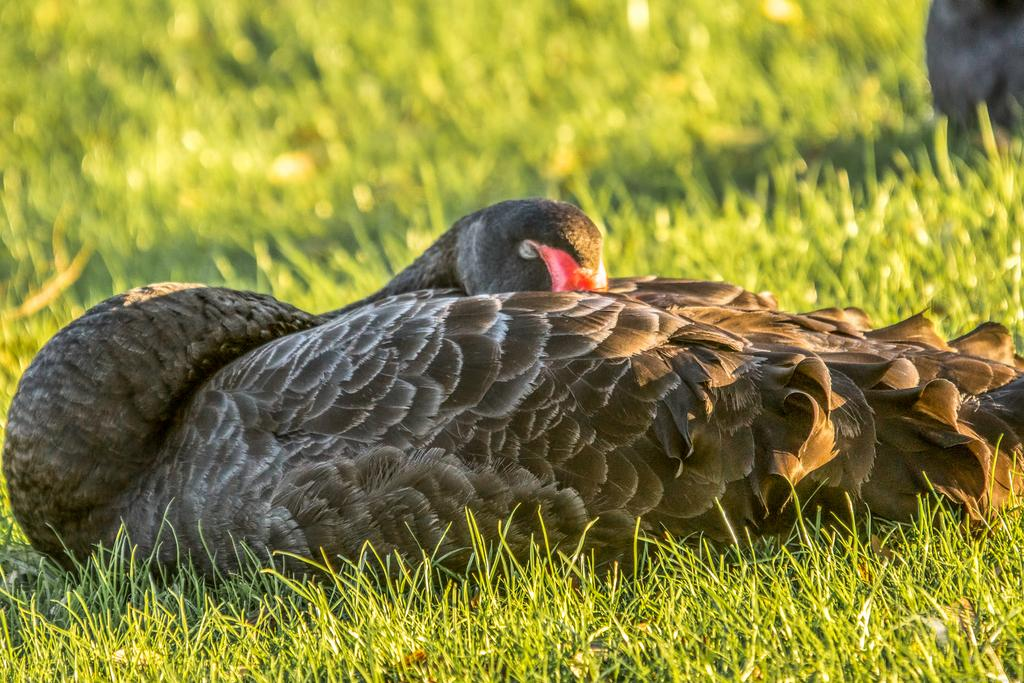What type of animal can be seen in the image? There is a bird in the image. Where is the bird located? The bird is sitting on the grass. What is the surface on which the bird is sitting? The grass is on the ground. Can you describe the background of the image? The background of the image is blurred. What type of cherries can be seen in the image? There are no cherries present in the image. What religious symbol can be seen in the image? There is no religious symbol present in the image. 